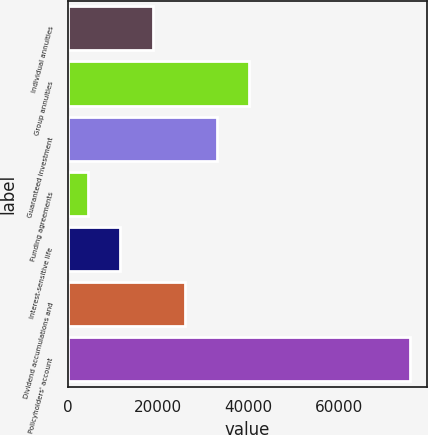Convert chart. <chart><loc_0><loc_0><loc_500><loc_500><bar_chart><fcel>Individual annuities<fcel>Group annuities<fcel>Guaranteed investment<fcel>Funding agreements<fcel>Interest-sensitive life<fcel>Dividend accumulations and<fcel>Policyholders' account<nl><fcel>18759.8<fcel>40097<fcel>32984.6<fcel>4535<fcel>11647.4<fcel>25872.2<fcel>75659<nl></chart> 